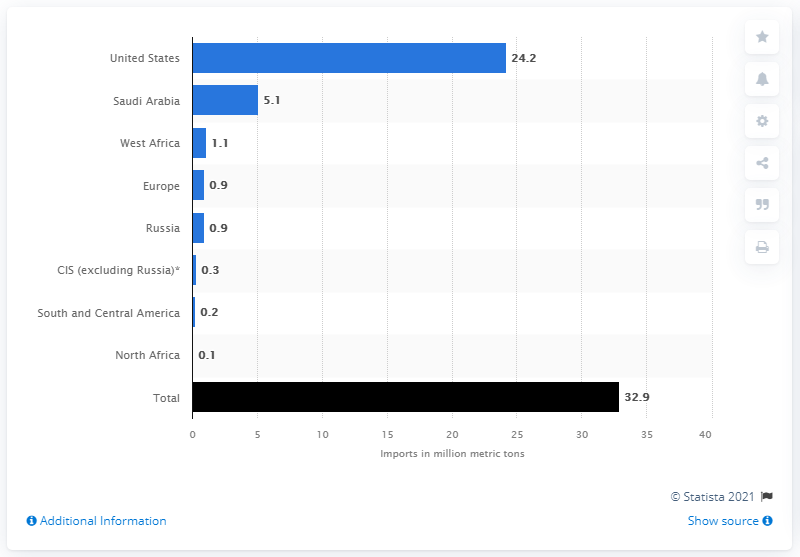Outline some significant characteristics in this image. In 2019, Canada imported a total of 24.2 million barrels of crude oil from the United States. 